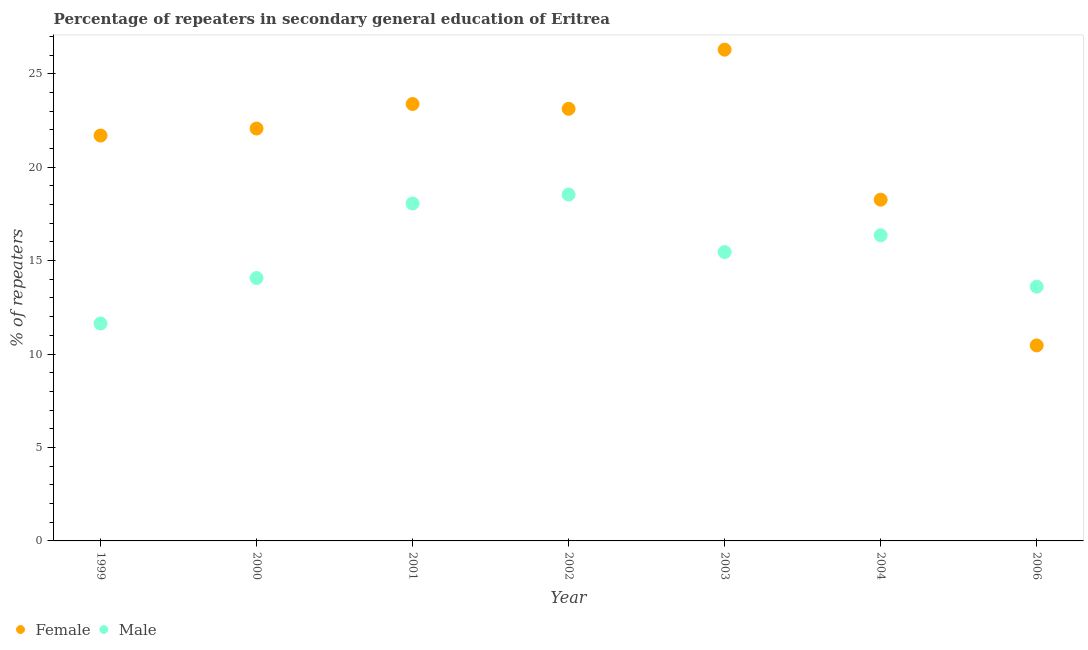How many different coloured dotlines are there?
Provide a succinct answer. 2. What is the percentage of male repeaters in 2006?
Keep it short and to the point. 13.61. Across all years, what is the maximum percentage of male repeaters?
Make the answer very short. 18.54. Across all years, what is the minimum percentage of female repeaters?
Offer a terse response. 10.46. What is the total percentage of female repeaters in the graph?
Give a very brief answer. 145.27. What is the difference between the percentage of male repeaters in 2003 and that in 2006?
Ensure brevity in your answer.  1.85. What is the difference between the percentage of female repeaters in 2000 and the percentage of male repeaters in 2004?
Offer a terse response. 5.71. What is the average percentage of male repeaters per year?
Give a very brief answer. 15.39. In the year 2000, what is the difference between the percentage of female repeaters and percentage of male repeaters?
Your answer should be very brief. 8. In how many years, is the percentage of female repeaters greater than 10 %?
Ensure brevity in your answer.  7. What is the ratio of the percentage of female repeaters in 1999 to that in 2002?
Your answer should be compact. 0.94. What is the difference between the highest and the second highest percentage of male repeaters?
Your response must be concise. 0.48. What is the difference between the highest and the lowest percentage of male repeaters?
Your answer should be compact. 6.9. In how many years, is the percentage of male repeaters greater than the average percentage of male repeaters taken over all years?
Offer a very short reply. 4. Does the percentage of female repeaters monotonically increase over the years?
Your answer should be compact. No. Is the percentage of female repeaters strictly less than the percentage of male repeaters over the years?
Your answer should be very brief. No. How many dotlines are there?
Offer a very short reply. 2. Are the values on the major ticks of Y-axis written in scientific E-notation?
Your response must be concise. No. Does the graph contain any zero values?
Your answer should be very brief. No. Where does the legend appear in the graph?
Ensure brevity in your answer.  Bottom left. How are the legend labels stacked?
Make the answer very short. Horizontal. What is the title of the graph?
Provide a succinct answer. Percentage of repeaters in secondary general education of Eritrea. What is the label or title of the Y-axis?
Provide a succinct answer. % of repeaters. What is the % of repeaters of Female in 1999?
Keep it short and to the point. 21.69. What is the % of repeaters of Male in 1999?
Your response must be concise. 11.64. What is the % of repeaters of Female in 2000?
Offer a very short reply. 22.07. What is the % of repeaters of Male in 2000?
Ensure brevity in your answer.  14.07. What is the % of repeaters of Female in 2001?
Your response must be concise. 23.38. What is the % of repeaters in Male in 2001?
Your answer should be compact. 18.06. What is the % of repeaters in Female in 2002?
Make the answer very short. 23.12. What is the % of repeaters in Male in 2002?
Your answer should be very brief. 18.54. What is the % of repeaters in Female in 2003?
Provide a short and direct response. 26.29. What is the % of repeaters in Male in 2003?
Your answer should be compact. 15.46. What is the % of repeaters in Female in 2004?
Offer a very short reply. 18.26. What is the % of repeaters in Male in 2004?
Keep it short and to the point. 16.35. What is the % of repeaters in Female in 2006?
Your response must be concise. 10.46. What is the % of repeaters of Male in 2006?
Ensure brevity in your answer.  13.61. Across all years, what is the maximum % of repeaters in Female?
Give a very brief answer. 26.29. Across all years, what is the maximum % of repeaters in Male?
Provide a short and direct response. 18.54. Across all years, what is the minimum % of repeaters in Female?
Your response must be concise. 10.46. Across all years, what is the minimum % of repeaters in Male?
Offer a very short reply. 11.64. What is the total % of repeaters of Female in the graph?
Provide a short and direct response. 145.27. What is the total % of repeaters of Male in the graph?
Your answer should be compact. 107.71. What is the difference between the % of repeaters in Female in 1999 and that in 2000?
Offer a very short reply. -0.38. What is the difference between the % of repeaters of Male in 1999 and that in 2000?
Provide a succinct answer. -2.43. What is the difference between the % of repeaters in Female in 1999 and that in 2001?
Provide a succinct answer. -1.69. What is the difference between the % of repeaters in Male in 1999 and that in 2001?
Provide a short and direct response. -6.42. What is the difference between the % of repeaters in Female in 1999 and that in 2002?
Ensure brevity in your answer.  -1.43. What is the difference between the % of repeaters of Male in 1999 and that in 2002?
Keep it short and to the point. -6.9. What is the difference between the % of repeaters in Female in 1999 and that in 2003?
Offer a terse response. -4.6. What is the difference between the % of repeaters of Male in 1999 and that in 2003?
Offer a terse response. -3.82. What is the difference between the % of repeaters of Female in 1999 and that in 2004?
Make the answer very short. 3.43. What is the difference between the % of repeaters in Male in 1999 and that in 2004?
Offer a terse response. -4.72. What is the difference between the % of repeaters in Female in 1999 and that in 2006?
Your answer should be very brief. 11.23. What is the difference between the % of repeaters in Male in 1999 and that in 2006?
Ensure brevity in your answer.  -1.97. What is the difference between the % of repeaters of Female in 2000 and that in 2001?
Your answer should be compact. -1.31. What is the difference between the % of repeaters of Male in 2000 and that in 2001?
Provide a succinct answer. -3.99. What is the difference between the % of repeaters of Female in 2000 and that in 2002?
Your response must be concise. -1.06. What is the difference between the % of repeaters of Male in 2000 and that in 2002?
Your answer should be very brief. -4.47. What is the difference between the % of repeaters of Female in 2000 and that in 2003?
Your response must be concise. -4.22. What is the difference between the % of repeaters in Male in 2000 and that in 2003?
Your answer should be very brief. -1.39. What is the difference between the % of repeaters of Female in 2000 and that in 2004?
Offer a terse response. 3.81. What is the difference between the % of repeaters of Male in 2000 and that in 2004?
Provide a short and direct response. -2.29. What is the difference between the % of repeaters in Female in 2000 and that in 2006?
Your answer should be compact. 11.61. What is the difference between the % of repeaters of Male in 2000 and that in 2006?
Offer a terse response. 0.46. What is the difference between the % of repeaters of Female in 2001 and that in 2002?
Offer a terse response. 0.26. What is the difference between the % of repeaters of Male in 2001 and that in 2002?
Give a very brief answer. -0.48. What is the difference between the % of repeaters of Female in 2001 and that in 2003?
Your response must be concise. -2.91. What is the difference between the % of repeaters of Male in 2001 and that in 2003?
Give a very brief answer. 2.6. What is the difference between the % of repeaters of Female in 2001 and that in 2004?
Provide a short and direct response. 5.12. What is the difference between the % of repeaters of Male in 2001 and that in 2004?
Make the answer very short. 1.7. What is the difference between the % of repeaters in Female in 2001 and that in 2006?
Your answer should be very brief. 12.92. What is the difference between the % of repeaters of Male in 2001 and that in 2006?
Your answer should be compact. 4.45. What is the difference between the % of repeaters of Female in 2002 and that in 2003?
Offer a terse response. -3.16. What is the difference between the % of repeaters in Male in 2002 and that in 2003?
Your response must be concise. 3.08. What is the difference between the % of repeaters in Female in 2002 and that in 2004?
Give a very brief answer. 4.86. What is the difference between the % of repeaters of Male in 2002 and that in 2004?
Ensure brevity in your answer.  2.18. What is the difference between the % of repeaters of Female in 2002 and that in 2006?
Offer a terse response. 12.66. What is the difference between the % of repeaters in Male in 2002 and that in 2006?
Ensure brevity in your answer.  4.93. What is the difference between the % of repeaters of Female in 2003 and that in 2004?
Ensure brevity in your answer.  8.03. What is the difference between the % of repeaters in Male in 2003 and that in 2004?
Give a very brief answer. -0.9. What is the difference between the % of repeaters of Female in 2003 and that in 2006?
Provide a short and direct response. 15.83. What is the difference between the % of repeaters in Male in 2003 and that in 2006?
Ensure brevity in your answer.  1.85. What is the difference between the % of repeaters in Female in 2004 and that in 2006?
Make the answer very short. 7.8. What is the difference between the % of repeaters in Male in 2004 and that in 2006?
Provide a short and direct response. 2.75. What is the difference between the % of repeaters in Female in 1999 and the % of repeaters in Male in 2000?
Make the answer very short. 7.62. What is the difference between the % of repeaters in Female in 1999 and the % of repeaters in Male in 2001?
Offer a very short reply. 3.63. What is the difference between the % of repeaters of Female in 1999 and the % of repeaters of Male in 2002?
Offer a very short reply. 3.16. What is the difference between the % of repeaters in Female in 1999 and the % of repeaters in Male in 2003?
Give a very brief answer. 6.24. What is the difference between the % of repeaters in Female in 1999 and the % of repeaters in Male in 2004?
Offer a terse response. 5.34. What is the difference between the % of repeaters in Female in 1999 and the % of repeaters in Male in 2006?
Your response must be concise. 8.09. What is the difference between the % of repeaters in Female in 2000 and the % of repeaters in Male in 2001?
Make the answer very short. 4.01. What is the difference between the % of repeaters in Female in 2000 and the % of repeaters in Male in 2002?
Ensure brevity in your answer.  3.53. What is the difference between the % of repeaters of Female in 2000 and the % of repeaters of Male in 2003?
Your answer should be very brief. 6.61. What is the difference between the % of repeaters of Female in 2000 and the % of repeaters of Male in 2004?
Give a very brief answer. 5.71. What is the difference between the % of repeaters in Female in 2000 and the % of repeaters in Male in 2006?
Provide a succinct answer. 8.46. What is the difference between the % of repeaters of Female in 2001 and the % of repeaters of Male in 2002?
Ensure brevity in your answer.  4.84. What is the difference between the % of repeaters in Female in 2001 and the % of repeaters in Male in 2003?
Your response must be concise. 7.92. What is the difference between the % of repeaters in Female in 2001 and the % of repeaters in Male in 2004?
Keep it short and to the point. 7.02. What is the difference between the % of repeaters of Female in 2001 and the % of repeaters of Male in 2006?
Offer a very short reply. 9.77. What is the difference between the % of repeaters of Female in 2002 and the % of repeaters of Male in 2003?
Offer a terse response. 7.67. What is the difference between the % of repeaters of Female in 2002 and the % of repeaters of Male in 2004?
Your response must be concise. 6.77. What is the difference between the % of repeaters in Female in 2002 and the % of repeaters in Male in 2006?
Make the answer very short. 9.52. What is the difference between the % of repeaters of Female in 2003 and the % of repeaters of Male in 2004?
Provide a short and direct response. 9.93. What is the difference between the % of repeaters of Female in 2003 and the % of repeaters of Male in 2006?
Your response must be concise. 12.68. What is the difference between the % of repeaters in Female in 2004 and the % of repeaters in Male in 2006?
Ensure brevity in your answer.  4.65. What is the average % of repeaters in Female per year?
Offer a very short reply. 20.75. What is the average % of repeaters of Male per year?
Your answer should be very brief. 15.39. In the year 1999, what is the difference between the % of repeaters in Female and % of repeaters in Male?
Offer a terse response. 10.06. In the year 2000, what is the difference between the % of repeaters in Female and % of repeaters in Male?
Offer a terse response. 8. In the year 2001, what is the difference between the % of repeaters of Female and % of repeaters of Male?
Your answer should be very brief. 5.32. In the year 2002, what is the difference between the % of repeaters of Female and % of repeaters of Male?
Provide a short and direct response. 4.59. In the year 2003, what is the difference between the % of repeaters of Female and % of repeaters of Male?
Ensure brevity in your answer.  10.83. In the year 2004, what is the difference between the % of repeaters of Female and % of repeaters of Male?
Make the answer very short. 1.91. In the year 2006, what is the difference between the % of repeaters in Female and % of repeaters in Male?
Your answer should be compact. -3.15. What is the ratio of the % of repeaters in Female in 1999 to that in 2000?
Provide a short and direct response. 0.98. What is the ratio of the % of repeaters in Male in 1999 to that in 2000?
Ensure brevity in your answer.  0.83. What is the ratio of the % of repeaters in Female in 1999 to that in 2001?
Your response must be concise. 0.93. What is the ratio of the % of repeaters in Male in 1999 to that in 2001?
Your response must be concise. 0.64. What is the ratio of the % of repeaters in Female in 1999 to that in 2002?
Keep it short and to the point. 0.94. What is the ratio of the % of repeaters of Male in 1999 to that in 2002?
Give a very brief answer. 0.63. What is the ratio of the % of repeaters of Female in 1999 to that in 2003?
Ensure brevity in your answer.  0.83. What is the ratio of the % of repeaters in Male in 1999 to that in 2003?
Provide a succinct answer. 0.75. What is the ratio of the % of repeaters of Female in 1999 to that in 2004?
Offer a very short reply. 1.19. What is the ratio of the % of repeaters of Male in 1999 to that in 2004?
Provide a short and direct response. 0.71. What is the ratio of the % of repeaters of Female in 1999 to that in 2006?
Your response must be concise. 2.07. What is the ratio of the % of repeaters in Male in 1999 to that in 2006?
Keep it short and to the point. 0.86. What is the ratio of the % of repeaters of Female in 2000 to that in 2001?
Your answer should be very brief. 0.94. What is the ratio of the % of repeaters in Male in 2000 to that in 2001?
Provide a succinct answer. 0.78. What is the ratio of the % of repeaters in Female in 2000 to that in 2002?
Your answer should be very brief. 0.95. What is the ratio of the % of repeaters of Male in 2000 to that in 2002?
Give a very brief answer. 0.76. What is the ratio of the % of repeaters of Female in 2000 to that in 2003?
Your answer should be very brief. 0.84. What is the ratio of the % of repeaters of Male in 2000 to that in 2003?
Offer a terse response. 0.91. What is the ratio of the % of repeaters in Female in 2000 to that in 2004?
Provide a short and direct response. 1.21. What is the ratio of the % of repeaters of Male in 2000 to that in 2004?
Ensure brevity in your answer.  0.86. What is the ratio of the % of repeaters in Female in 2000 to that in 2006?
Give a very brief answer. 2.11. What is the ratio of the % of repeaters of Male in 2000 to that in 2006?
Provide a succinct answer. 1.03. What is the ratio of the % of repeaters of Female in 2001 to that in 2002?
Make the answer very short. 1.01. What is the ratio of the % of repeaters in Male in 2001 to that in 2002?
Ensure brevity in your answer.  0.97. What is the ratio of the % of repeaters in Female in 2001 to that in 2003?
Offer a terse response. 0.89. What is the ratio of the % of repeaters of Male in 2001 to that in 2003?
Make the answer very short. 1.17. What is the ratio of the % of repeaters in Female in 2001 to that in 2004?
Your response must be concise. 1.28. What is the ratio of the % of repeaters in Male in 2001 to that in 2004?
Your answer should be very brief. 1.1. What is the ratio of the % of repeaters in Female in 2001 to that in 2006?
Your answer should be compact. 2.23. What is the ratio of the % of repeaters of Male in 2001 to that in 2006?
Your answer should be compact. 1.33. What is the ratio of the % of repeaters in Female in 2002 to that in 2003?
Keep it short and to the point. 0.88. What is the ratio of the % of repeaters in Male in 2002 to that in 2003?
Provide a succinct answer. 1.2. What is the ratio of the % of repeaters in Female in 2002 to that in 2004?
Offer a very short reply. 1.27. What is the ratio of the % of repeaters in Male in 2002 to that in 2004?
Offer a terse response. 1.13. What is the ratio of the % of repeaters of Female in 2002 to that in 2006?
Your answer should be very brief. 2.21. What is the ratio of the % of repeaters in Male in 2002 to that in 2006?
Make the answer very short. 1.36. What is the ratio of the % of repeaters of Female in 2003 to that in 2004?
Keep it short and to the point. 1.44. What is the ratio of the % of repeaters in Male in 2003 to that in 2004?
Ensure brevity in your answer.  0.95. What is the ratio of the % of repeaters of Female in 2003 to that in 2006?
Your response must be concise. 2.51. What is the ratio of the % of repeaters of Male in 2003 to that in 2006?
Provide a short and direct response. 1.14. What is the ratio of the % of repeaters of Female in 2004 to that in 2006?
Give a very brief answer. 1.75. What is the ratio of the % of repeaters of Male in 2004 to that in 2006?
Offer a terse response. 1.2. What is the difference between the highest and the second highest % of repeaters in Female?
Your answer should be very brief. 2.91. What is the difference between the highest and the second highest % of repeaters in Male?
Make the answer very short. 0.48. What is the difference between the highest and the lowest % of repeaters of Female?
Make the answer very short. 15.83. What is the difference between the highest and the lowest % of repeaters of Male?
Provide a short and direct response. 6.9. 